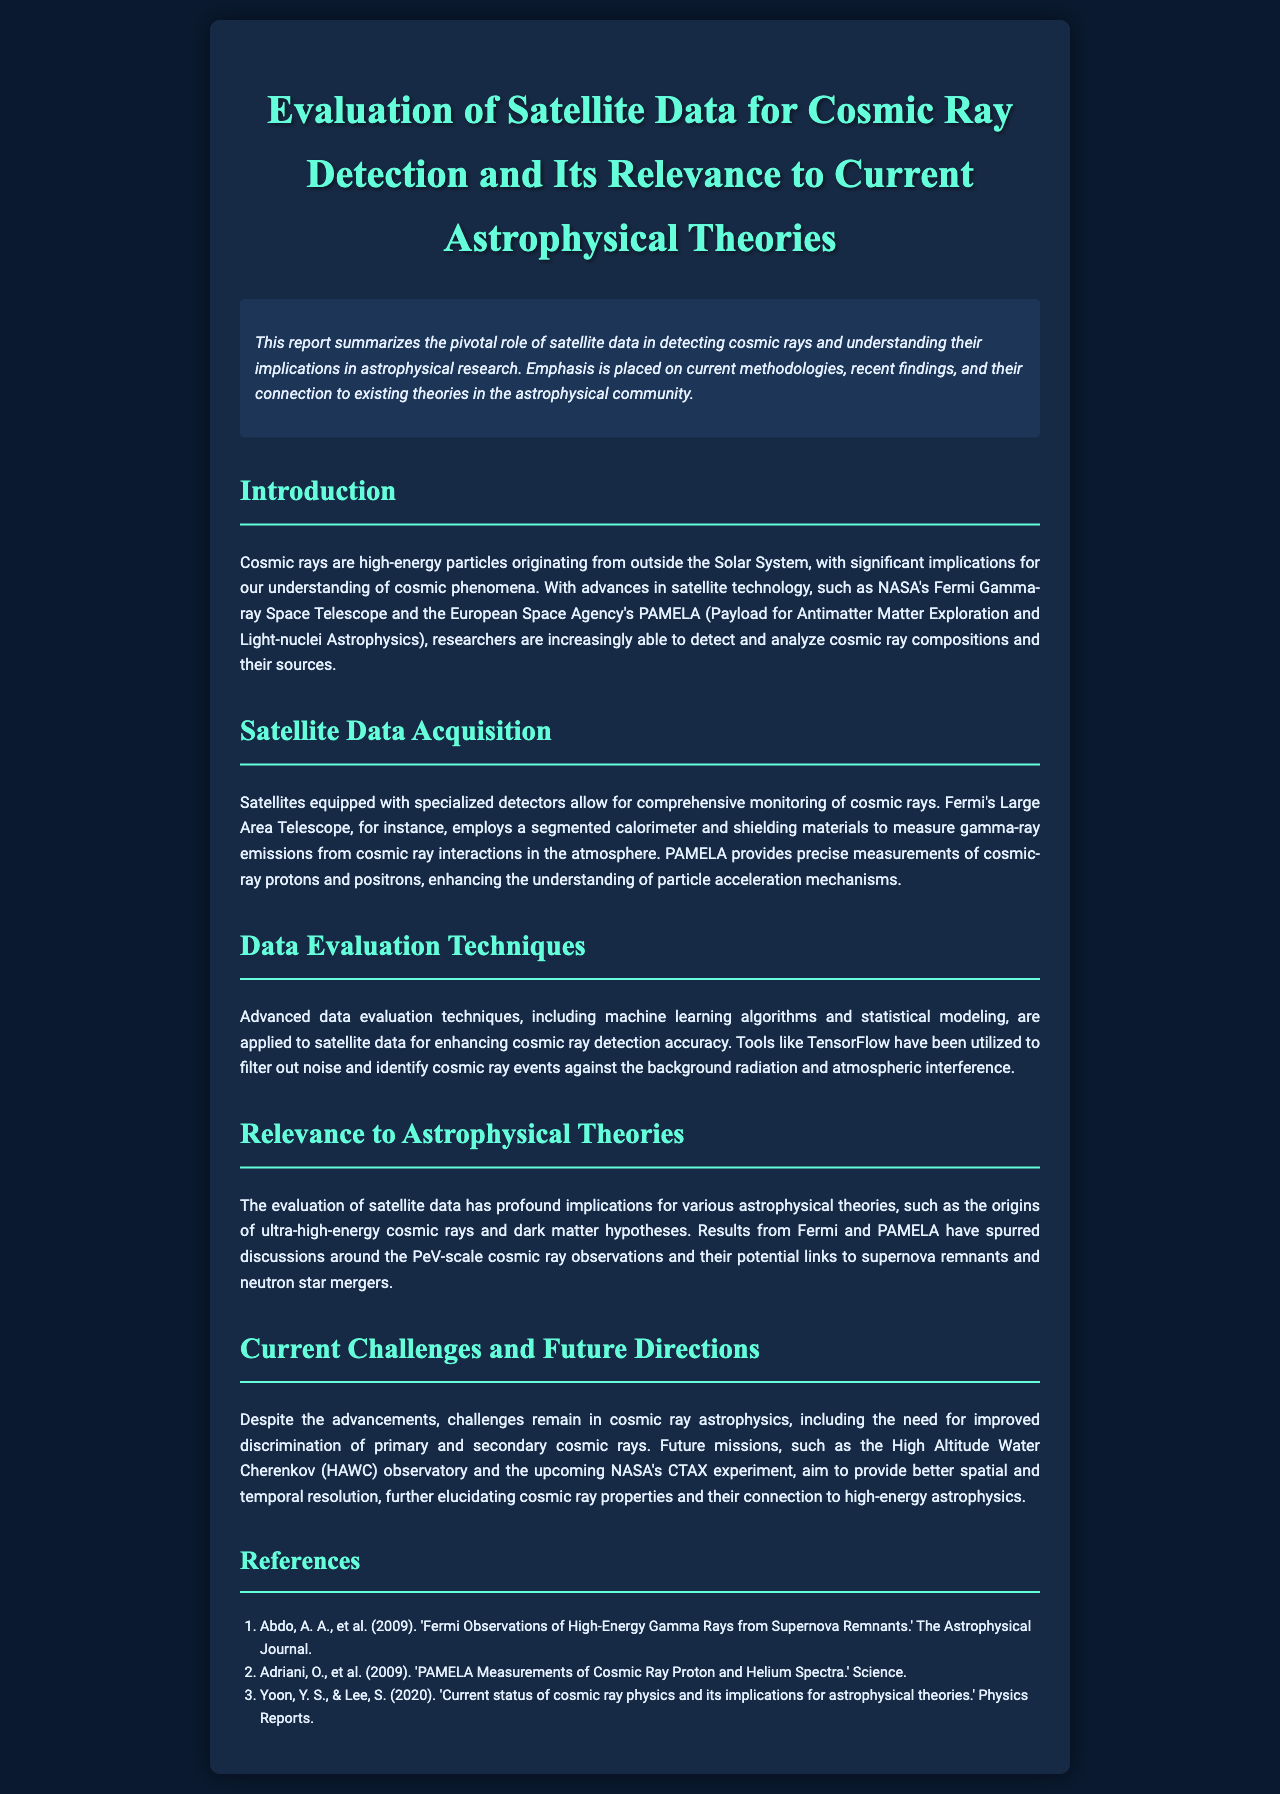What is the primary focus of the report? The report summarizes the pivotal role of satellite data in detecting cosmic rays and understanding their implications in astrophysical research.
Answer: cosmic rays Which satellites are mentioned for cosmic ray detection? The satellites specifically mentioned are NASA's Fermi Gamma-ray Space Telescope and the European Space Agency's PAMELA.
Answer: Fermi and PAMELA What advanced technique is applied to enhance cosmic ray detection accuracy? Advanced data evaluation techniques including machine learning algorithms and statistical modeling are applied for enhancing cosmic ray detection accuracy.
Answer: machine learning algorithms What does PAMELA provide precise measurements of? PAMELA provides precise measurements of cosmic-ray protons and positrons.
Answer: cosmic-ray protons and positrons What upcoming experiment aims to provide better resolution in cosmic ray properties? The upcoming NASA's CTAX experiment aims to provide better spatial and temporal resolution.
Answer: CTAX experiment How are cosmic rays relevant to astrophysical theories? The evaluation of satellite data has profound implications for various astrophysical theories, such as the origins of ultra-high-energy cosmic rays and dark matter hypotheses.
Answer: ultra-high-energy cosmic rays and dark matter hypotheses What is a significant challenge noted in cosmic ray astrophysics? A significant challenge mentioned is the need for improved discrimination of primary and secondary cosmic rays.
Answer: discrimination of primary and secondary cosmic rays 